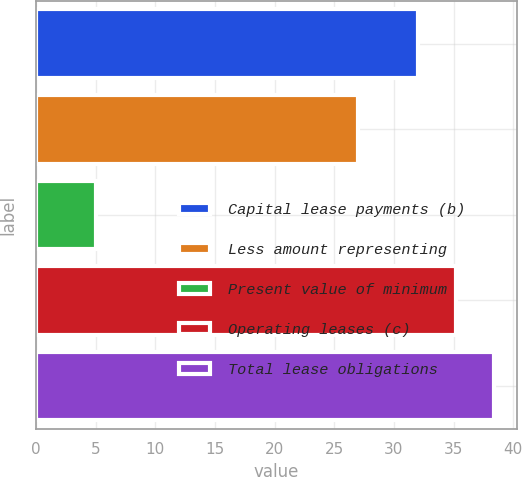Convert chart. <chart><loc_0><loc_0><loc_500><loc_500><bar_chart><fcel>Capital lease payments (b)<fcel>Less amount representing<fcel>Present value of minimum<fcel>Operating leases (c)<fcel>Total lease obligations<nl><fcel>32<fcel>27<fcel>5<fcel>35.2<fcel>38.4<nl></chart> 